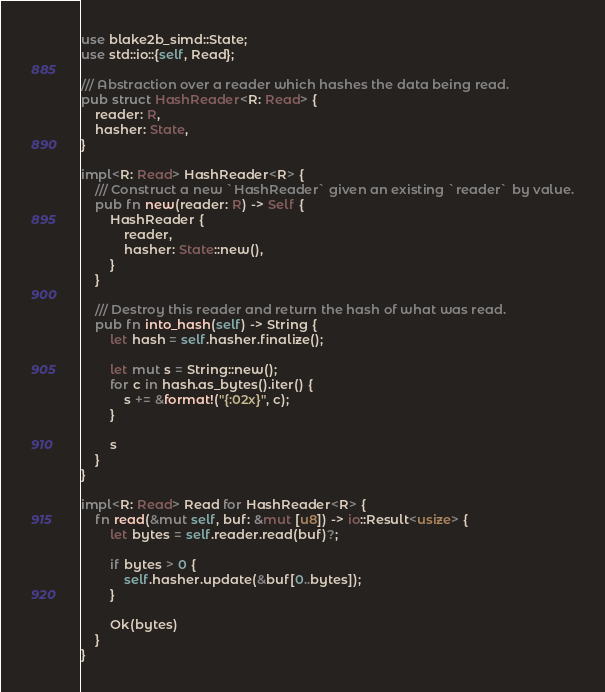Convert code to text. <code><loc_0><loc_0><loc_500><loc_500><_Rust_>use blake2b_simd::State;
use std::io::{self, Read};

/// Abstraction over a reader which hashes the data being read.
pub struct HashReader<R: Read> {
    reader: R,
    hasher: State,
}

impl<R: Read> HashReader<R> {
    /// Construct a new `HashReader` given an existing `reader` by value.
    pub fn new(reader: R) -> Self {
        HashReader {
            reader,
            hasher: State::new(),
        }
    }

    /// Destroy this reader and return the hash of what was read.
    pub fn into_hash(self) -> String {
        let hash = self.hasher.finalize();

        let mut s = String::new();
        for c in hash.as_bytes().iter() {
            s += &format!("{:02x}", c);
        }

        s
    }
}

impl<R: Read> Read for HashReader<R> {
    fn read(&mut self, buf: &mut [u8]) -> io::Result<usize> {
        let bytes = self.reader.read(buf)?;

        if bytes > 0 {
            self.hasher.update(&buf[0..bytes]);
        }

        Ok(bytes)
    }
}
</code> 